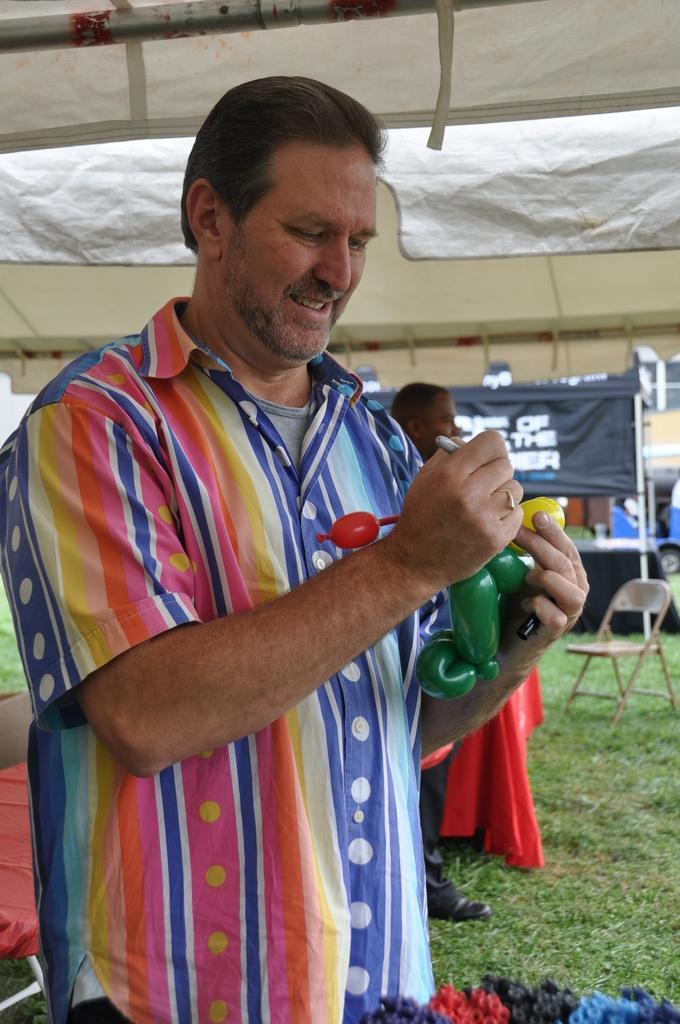In one or two sentences, can you explain what this image depicts? In the picture there is a man he is holding some object in his hand and there is another person standing behind the man he is holding some red cloth in his hand,in the background there is a stall and both the people are standing on the grass. 